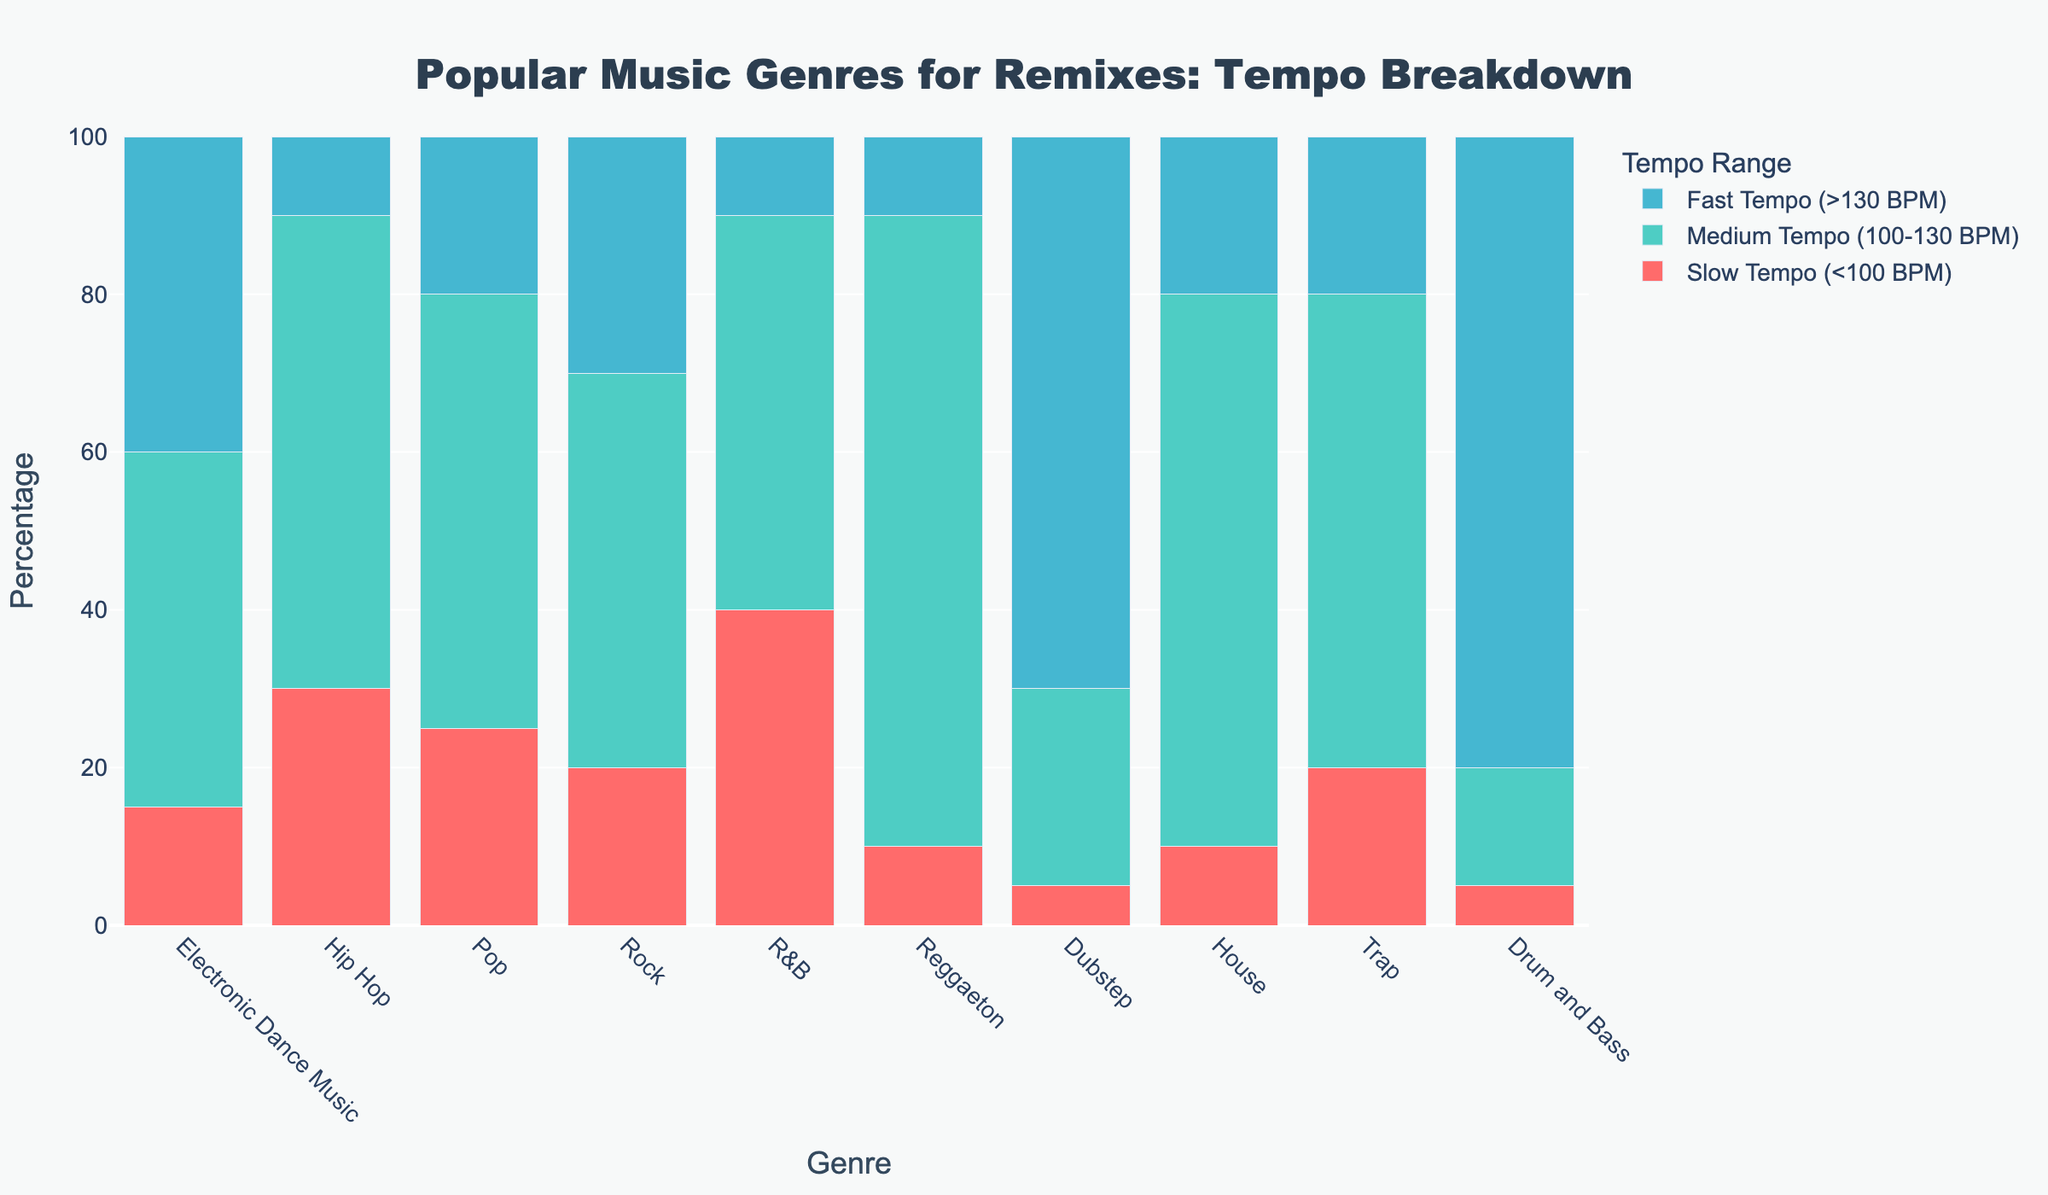What genre has the highest percentage of fast-tempo songs? By looking at the stacked bar chart, identify the genre with the longest blue bar representing the fast tempo range (>130 BPM).
Answer: Drum and Bass Which genre has the highest percentage of medium-tempo songs? By examining the chart, find the genre with the tallest green bar, indicating the medium tempo range (100-130 BPM).
Answer: Reggaeton What is the total percentage of slow-tempo songs in the R&B genre? The slow tempo percentage for the R&B genre is indicated by the height of the red portion of its bar.
Answer: 40% Which genre has a higher percentage of fast-tempo songs, Dubstep or Trap? Compare the lengths of the blue bars for Dubstep and Trap to determine which one is longer.
Answer: Dubstep What is the combined percentage of medium-tempo and fast-tempo songs in the Pop genre? Add the percentage values of medium tempo and fast tempo for the Pop genre: 55% (medium) + 20% (fast) = 75%.
Answer: 75% How many genres have more than 30% of their songs in the slow tempo range? Count the number of bars where the red section (slow tempo) is taller than 30%.
Answer: 2 (Hip Hop and R&B) Compared to Rock, does House have more or fewer songs in the medium tempo range? Compare the lengths of the green bars for Rock and House.
Answer: More What is the total percentage of fast-tempo songs across all genres? Sum the percentages of fast-tempo songs for all genres: 40 + 10 + 20 + 30 + 10 + 10 + 70 + 20 + 20 + 80 = 310%.
Answer: 310% Which genre has the lowest percentage of slow-tempo songs? Identify the shortest red bar in the chart, indicating the slow tempo range.
Answer: Drum and Bass In the Electronic Dance Music genre, what is the difference in percentage between medium-tempo and fast-tempo songs? Subtract the percentage of fast-tempo songs from the medium-tempo songs for the Electronic Dance Music genre: 45% (medium) - 40% (fast) = 5%.
Answer: 5% 